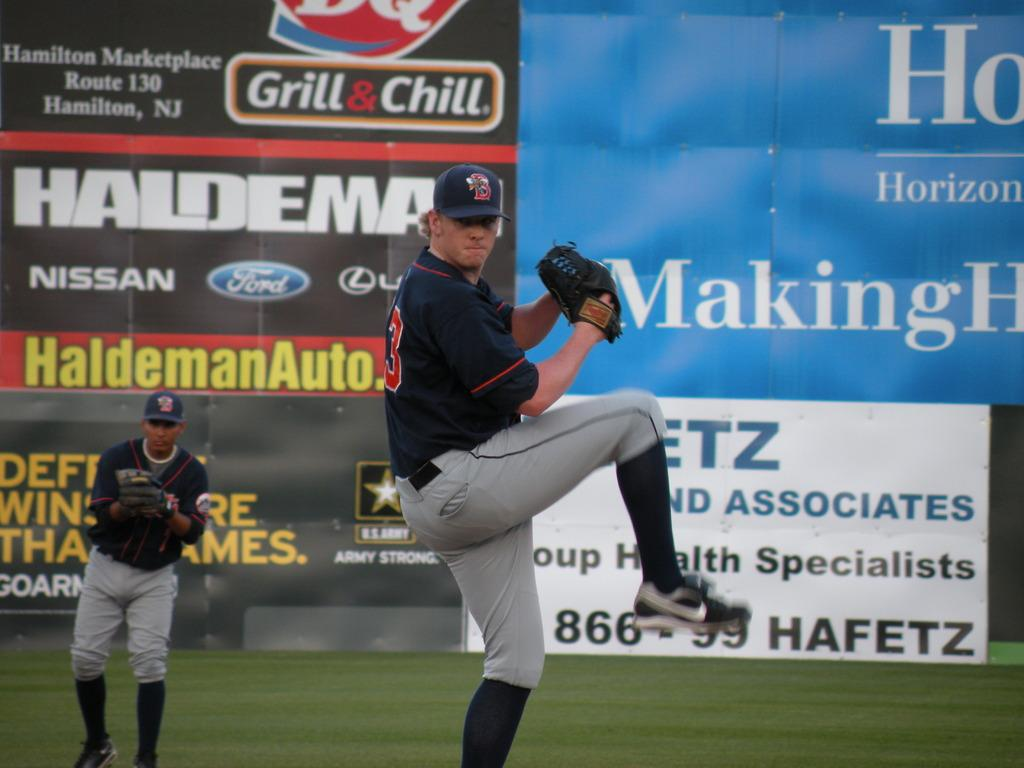<image>
Render a clear and concise summary of the photo. A baseball pitcher in front of an ad for DQ Grill & Chill. 